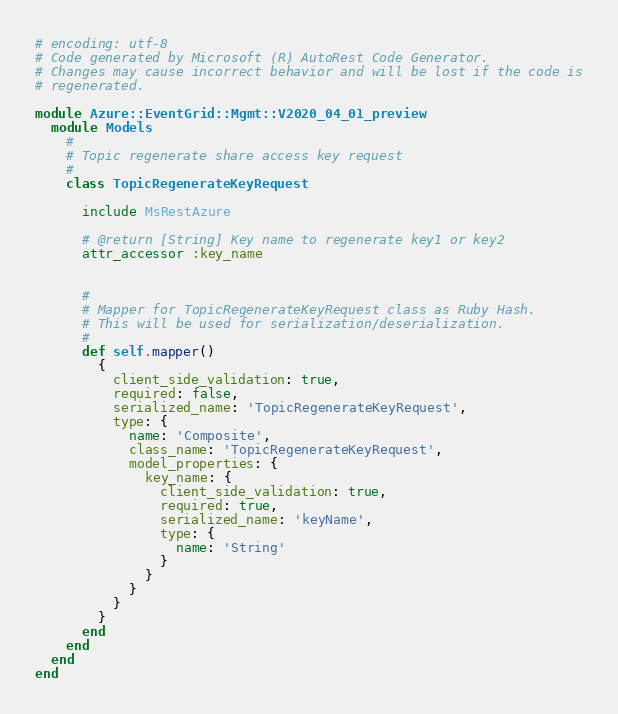<code> <loc_0><loc_0><loc_500><loc_500><_Ruby_># encoding: utf-8
# Code generated by Microsoft (R) AutoRest Code Generator.
# Changes may cause incorrect behavior and will be lost if the code is
# regenerated.

module Azure::EventGrid::Mgmt::V2020_04_01_preview
  module Models
    #
    # Topic regenerate share access key request
    #
    class TopicRegenerateKeyRequest

      include MsRestAzure

      # @return [String] Key name to regenerate key1 or key2
      attr_accessor :key_name


      #
      # Mapper for TopicRegenerateKeyRequest class as Ruby Hash.
      # This will be used for serialization/deserialization.
      #
      def self.mapper()
        {
          client_side_validation: true,
          required: false,
          serialized_name: 'TopicRegenerateKeyRequest',
          type: {
            name: 'Composite',
            class_name: 'TopicRegenerateKeyRequest',
            model_properties: {
              key_name: {
                client_side_validation: true,
                required: true,
                serialized_name: 'keyName',
                type: {
                  name: 'String'
                }
              }
            }
          }
        }
      end
    end
  end
end
</code> 